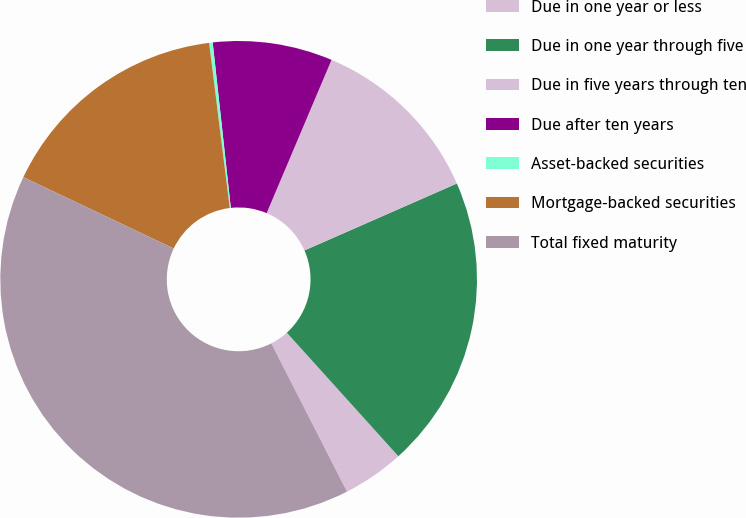Convert chart to OTSL. <chart><loc_0><loc_0><loc_500><loc_500><pie_chart><fcel>Due in one year or less<fcel>Due in one year through five<fcel>Due in five years through ten<fcel>Due after ten years<fcel>Asset-backed securities<fcel>Mortgage-backed securities<fcel>Total fixed maturity<nl><fcel>4.18%<fcel>19.9%<fcel>12.04%<fcel>8.11%<fcel>0.24%<fcel>15.97%<fcel>39.56%<nl></chart> 